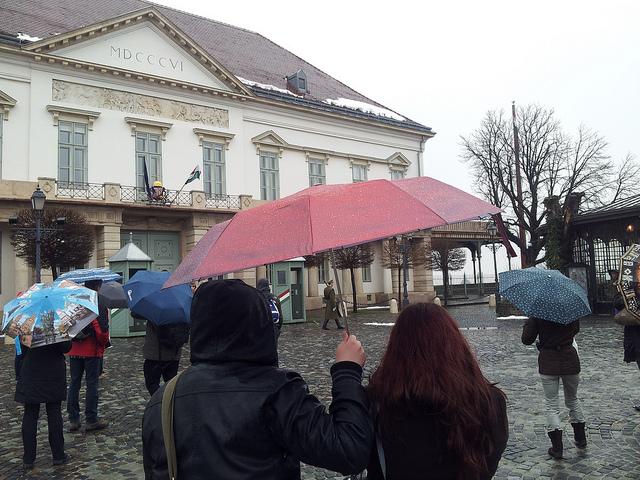Is this a two story building?
Concise answer only. Yes. Is it a sunny day?
Concise answer only. No. What color is the umbrella?
Concise answer only. Red. 